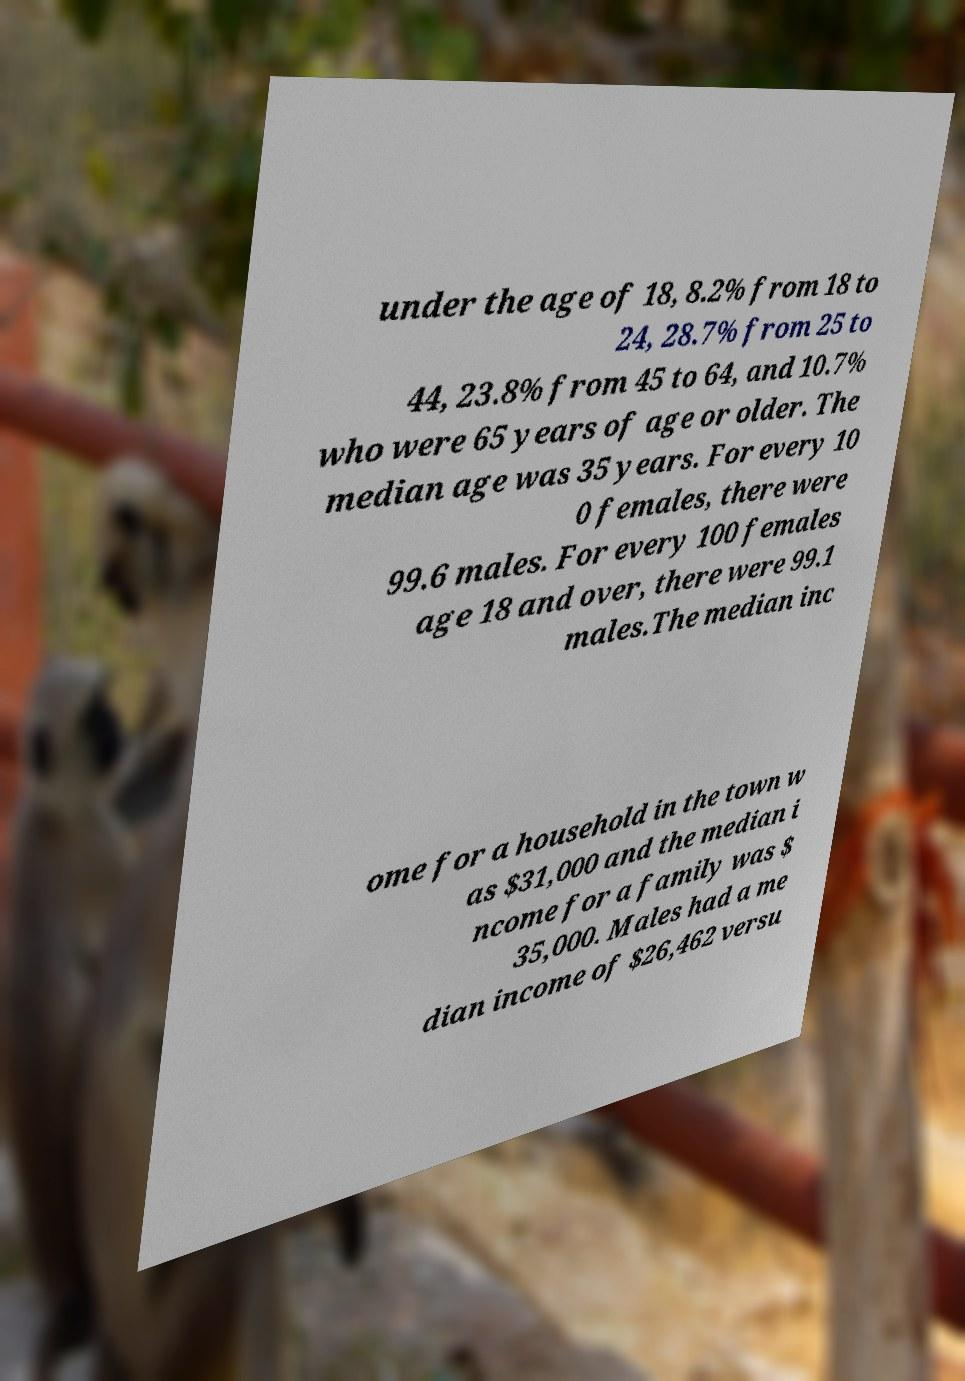Please identify and transcribe the text found in this image. under the age of 18, 8.2% from 18 to 24, 28.7% from 25 to 44, 23.8% from 45 to 64, and 10.7% who were 65 years of age or older. The median age was 35 years. For every 10 0 females, there were 99.6 males. For every 100 females age 18 and over, there were 99.1 males.The median inc ome for a household in the town w as $31,000 and the median i ncome for a family was $ 35,000. Males had a me dian income of $26,462 versu 